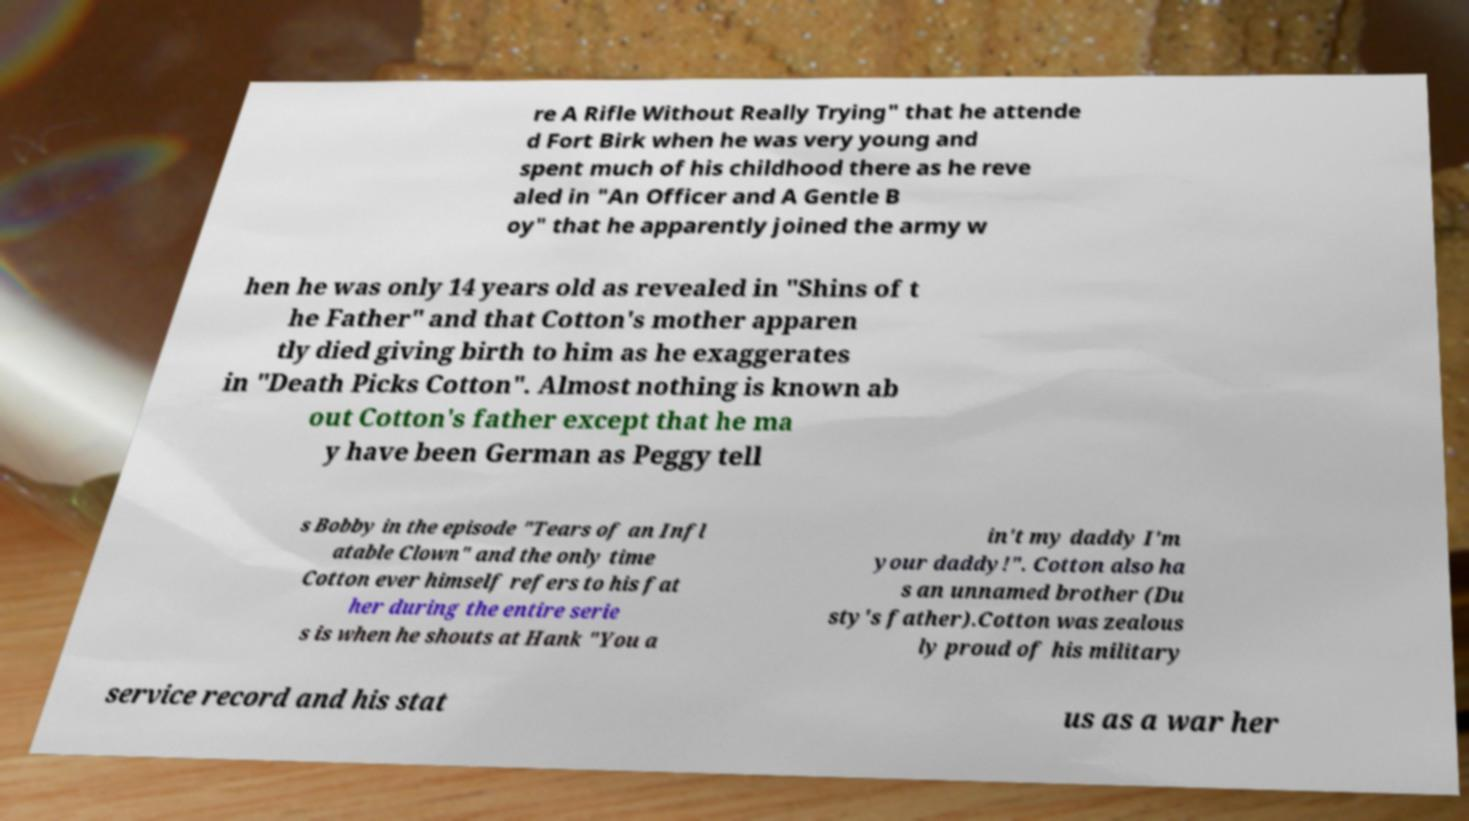Can you accurately transcribe the text from the provided image for me? re A Rifle Without Really Trying" that he attende d Fort Birk when he was very young and spent much of his childhood there as he reve aled in "An Officer and A Gentle B oy" that he apparently joined the army w hen he was only 14 years old as revealed in "Shins of t he Father" and that Cotton's mother apparen tly died giving birth to him as he exaggerates in "Death Picks Cotton". Almost nothing is known ab out Cotton's father except that he ma y have been German as Peggy tell s Bobby in the episode "Tears of an Infl atable Clown" and the only time Cotton ever himself refers to his fat her during the entire serie s is when he shouts at Hank "You a in't my daddy I'm your daddy!". Cotton also ha s an unnamed brother (Du sty's father).Cotton was zealous ly proud of his military service record and his stat us as a war her 